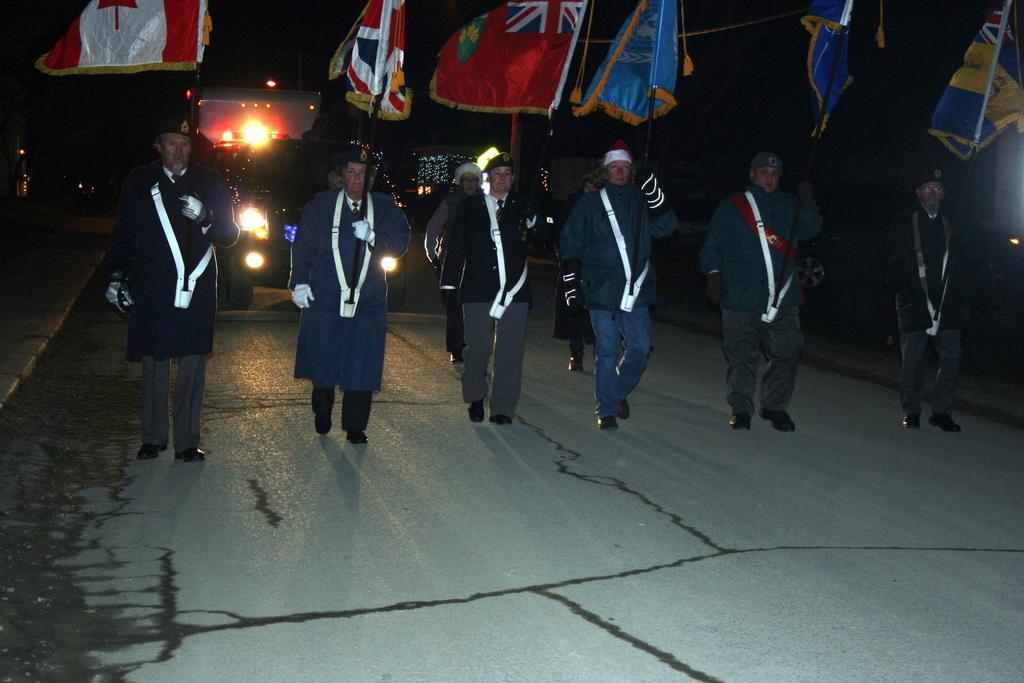Describe this image in one or two sentences. In this image there are people walking on the road. Behind them there are vehicles. They are holding the flags. They are wearing the caps and uniform. 